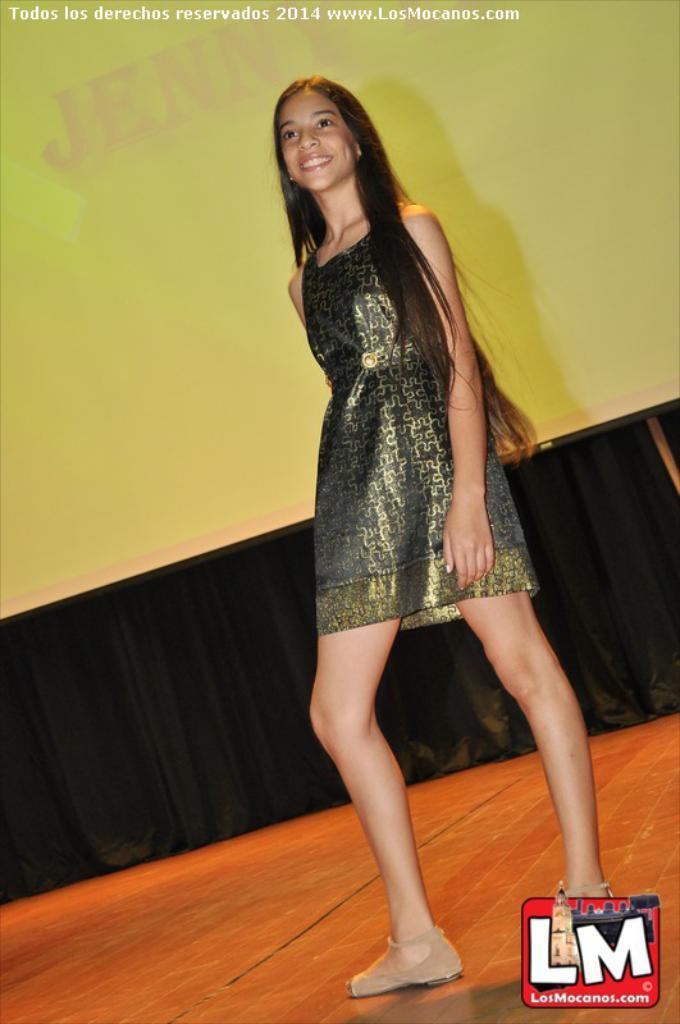Can you describe this image briefly? In this image we can see a lady person wearing green color dress standing on stage and in the background of the image there is yellow and black color curtain. 